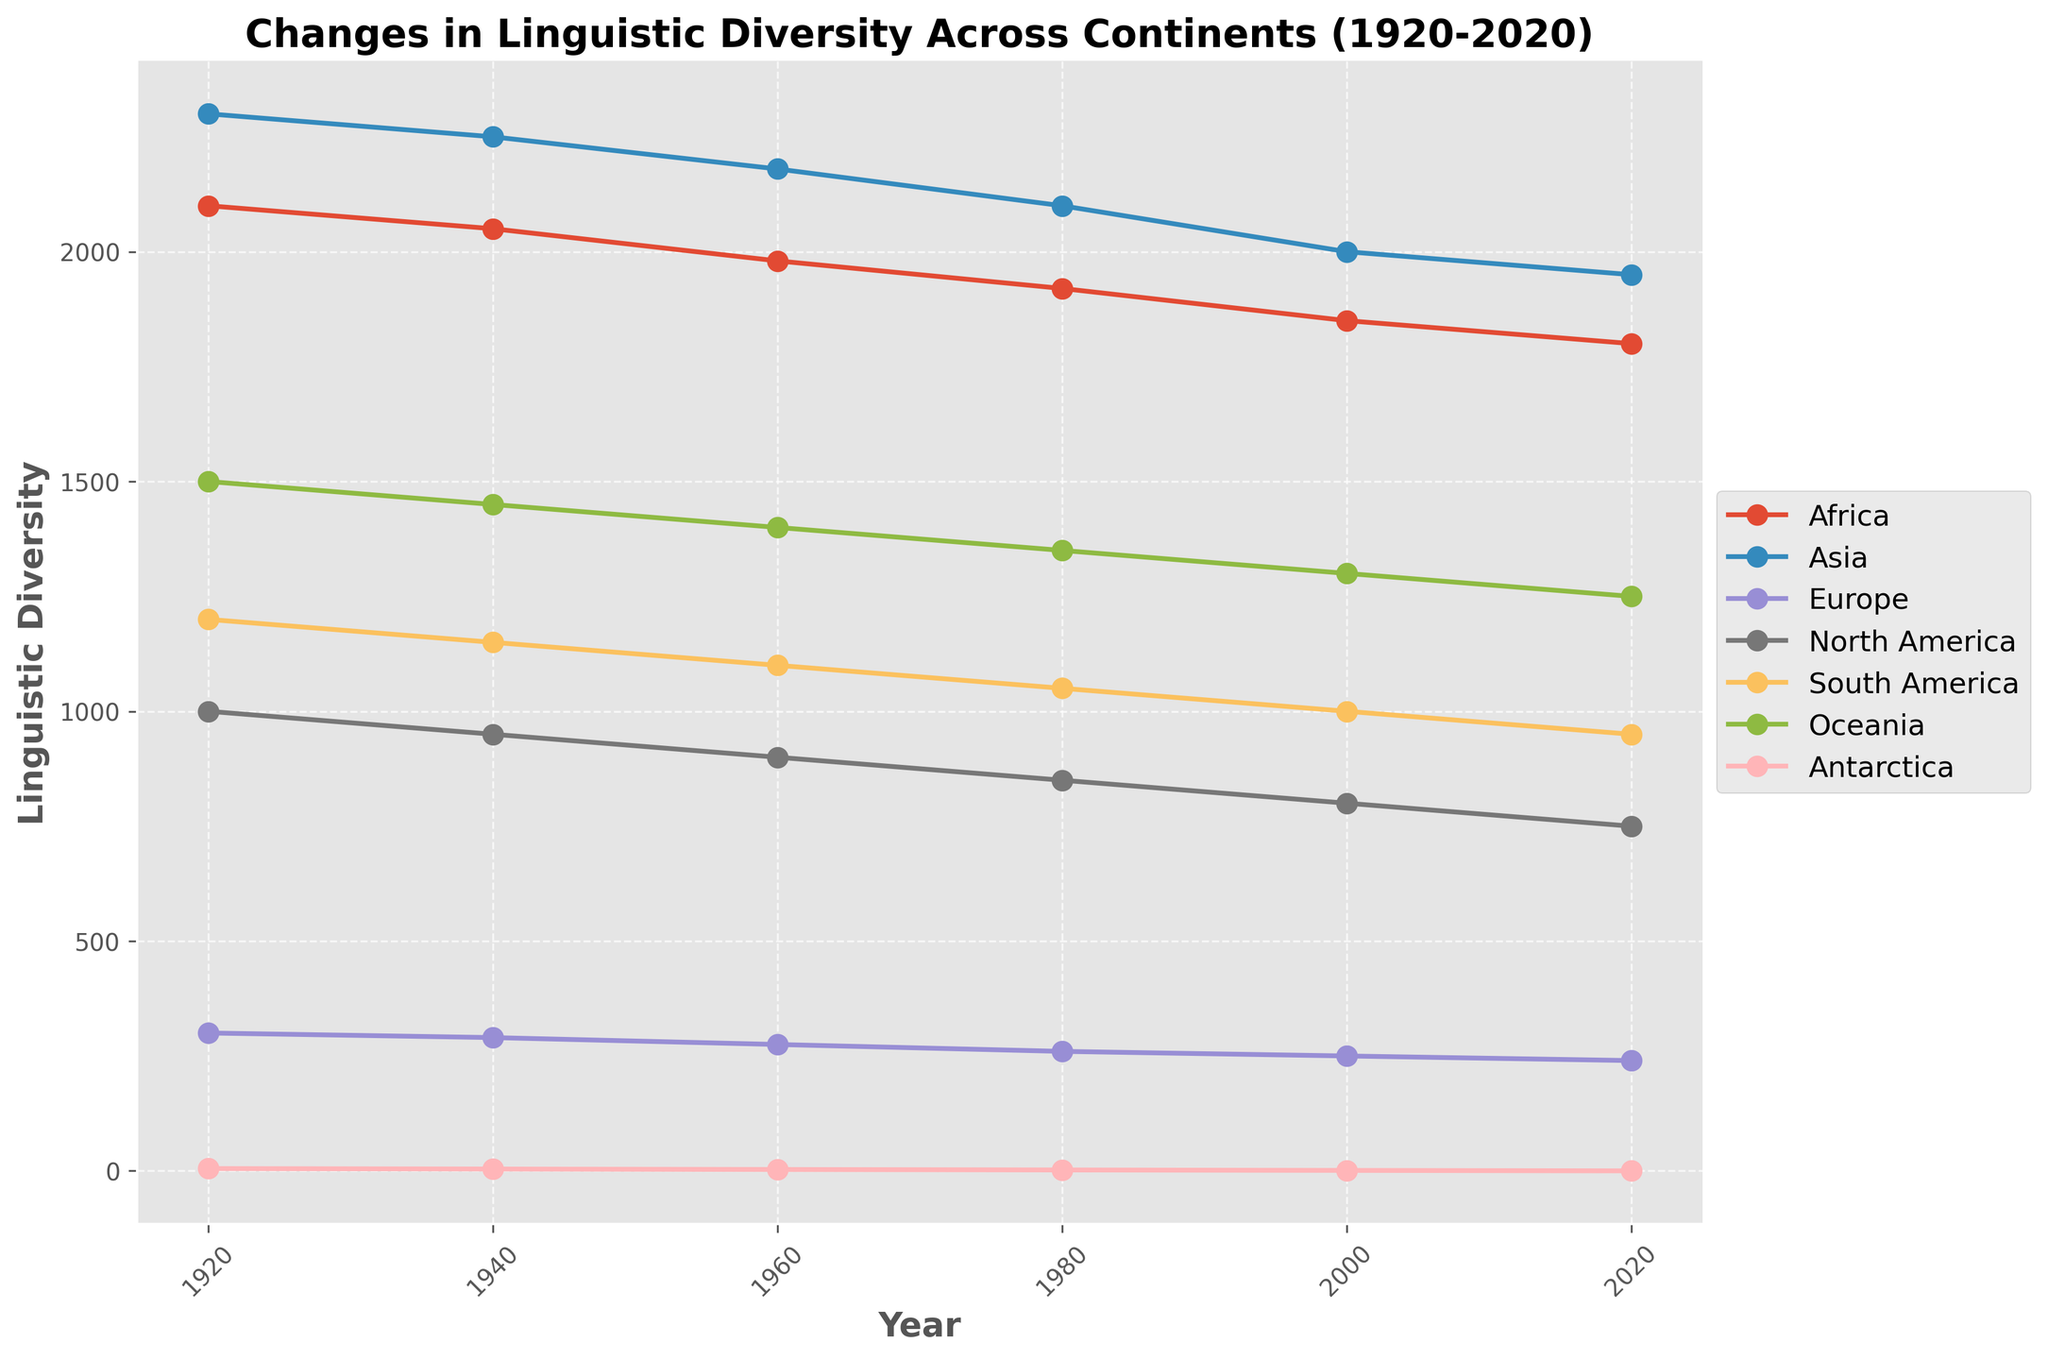What is the general trend of linguistic diversity in Africa from 1920 to 2020? To determine the trend, observe the line for Africa from 1920 to 2020. The plot shows a descending trend as the values decrease from 2100 in 1920 to 1800 in 2020.
Answer: Decreasing Which continent had the highest linguistic diversity in 1960 and what was its value? Look at the lines corresponding to each continent for the year 1960. The highest point in this year is on the line for Asia at 2180.
Answer: Asia, 2180 By how much did the linguistic diversity in North America decrease from 1920 to 2020? Find the values for North America in 1920 and 2020 (1000 and 750 respectively), then subtract the latter from the former: 1000 - 750 = 250.
Answer: 250 In which decade did Europe experience the smallest decrease in linguistic diversity? Calculate the decrease for each pair of decades for Europe:
- 1920-1940: 300 - 290 = 10
- 1940-1960: 290 - 275 = 15
- 1960-1980: 275 - 260 = 15
- 1980-2000: 260 - 250 = 10
- 2000-2020: 250 - 240 = 10
The smallest decrease (10) occurs in the decades 1920-1940, 1980-2000, and 2000-2020.
Answer: 1920-1940, 1980-2000, 2000-2020 Compare the linguistic diversity in South America and Oceania in 2000. Which is greater and by how much? Look at the plot values for South America and Oceania in 2000 (1000 and 1300 respectively). Subtract the South America value from the Oceania value: 1300 - 1000 = 300.
Answer: Oceania, 300 What is the average linguistic diversity in Antarctica over the past century? Sum the values for Antarctica from 1920 to 2020 (5 + 4 + 3 + 2 + 1 + 0 = 15), and divide by the number of data points (6). 15 / 6 = 2.5.
Answer: 2.5 Which continent has shown a consistent decrease in linguistic diversity across all measured years without any increase? Check each continent's line for consistency in decrease. Both Africa, Asia, Europe, North America, and South America lines decrease uniformly without any upward trend.
Answer: Africa, Asia, Europe, North America, South America Is there any continent that retained the same linguistic diversity between 1980 and 2000? Compare the values for each continent between 1980 and 2000. None of the continents have the same value in both years.
Answer: No Between 1960 and 2020, how many continents experienced a more than 400 point decrease in linguistic diversity? Calculate the decrease for each continent from 1960 to 2020:
- Africa: 1980 - 1800 = 180
- Asia: 2180 - 1950 = 230
- Europe: 275 - 240 = 35
- North America: 900 - 750 = 150
- South America: 1100 - 950 = 150
- Oceania: 1400 - 1250 = 150
- Antarctica: 3 - 0 = 3
None of the continents experienced a decrease of more than 400 points.
Answer: 0 